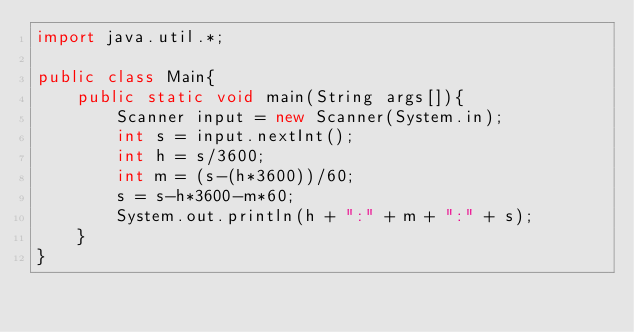<code> <loc_0><loc_0><loc_500><loc_500><_Java_>import java.util.*;

public class Main{
    public static void main(String args[]){
        Scanner input = new Scanner(System.in);
        int s = input.nextInt();
        int h = s/3600;
        int m = (s-(h*3600))/60;
        s = s-h*3600-m*60;
        System.out.println(h + ":" + m + ":" + s);
    }
}
</code> 